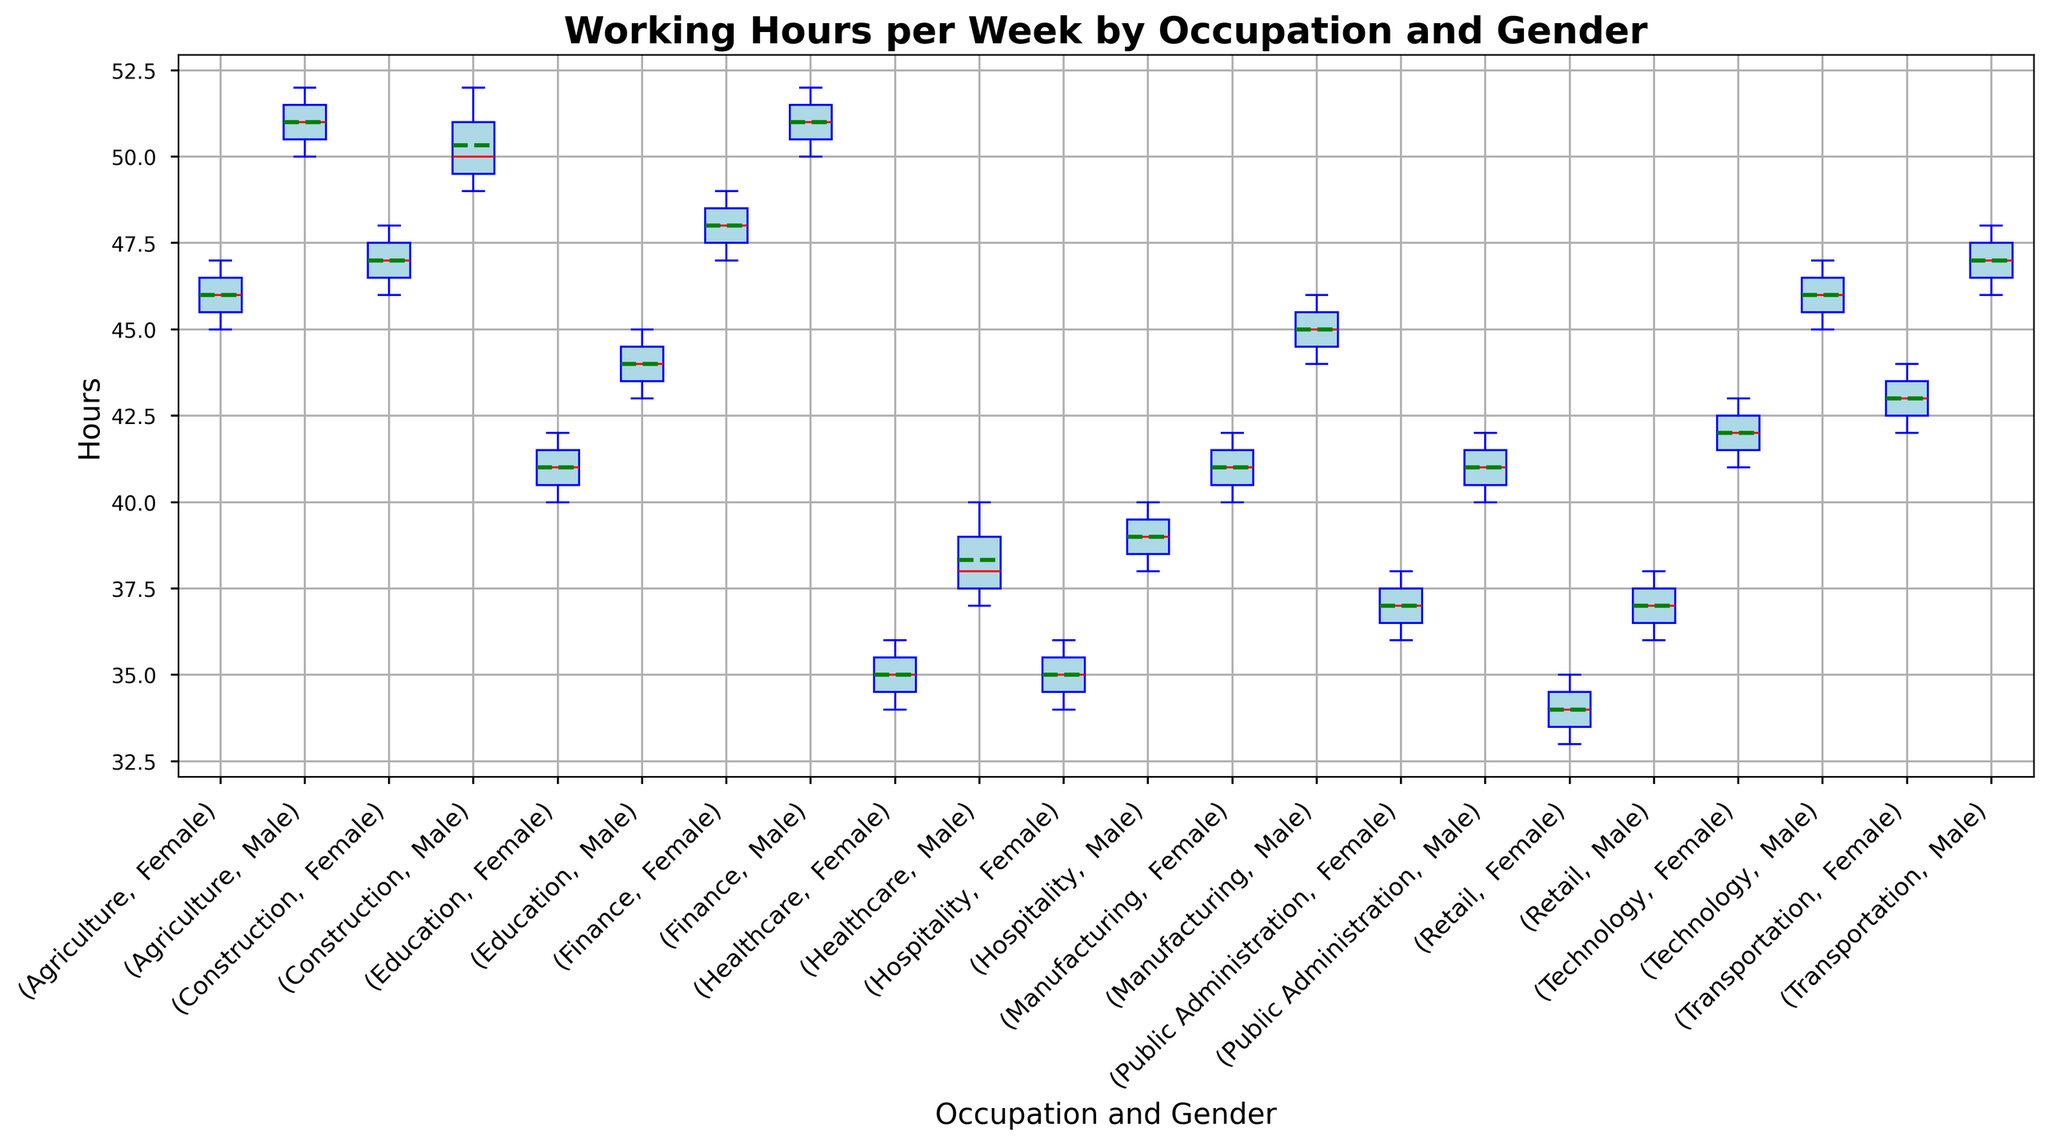What is the median working hours per week for females in the Healthcare sector? To find the median working hours for females in the Healthcare sector, locate the box plot corresponding to Healthcare females and observe the red line in the middle of the box.
Answer: 35 Which gender works more hours on average in the Finance sector? Compare the green dashed lines (representing the means) for males and females in the Finance sector. The mean is indicated by the green line, dashed for males and females.
Answer: Male What is the range of working hours for males in the Retail sector? For the range, identify the highest and lowest whiskers in the box plot for males in the Retail sector. Subtract the lowest value from the highest.
Answer: 2 Are the mean working hours for males in the Education sector greater than those of females in the same sector? Observe the green dashed lines for males and females in the Education box plot. Compare these lines to determine which is higher.
Answer: Yes Among males, which occupation has the highest median working hours? Look at the red median lines within the male box plots for all occupations, and identify the occupation where this line is the highest.
Answer: Finance Is the interquartile range (IQR) wider for males or females in the Healthcare sector? The IQR is the distance between the top and bottom edges of the box. Compare the heights of the boxes for males and females in the Healthcare sector.
Answer: Male Which occupation shows the smallest spread in working hours for either gender? Determine the spread by comparing the lengths of the whiskers and boxes across all occupations for both genders.
Answer: Retail Do females in the Technology sector have a higher median working hour than males in the Retail sector? Compare the red median line in the box plots for females in Technology and males in Retail.
Answer: Yes What is the difference in the average working hours between males in Construction and females in Agriculture? Locate the green dashed line (mean) for males in Construction and females in Agriculture, and calculate the difference.
Answer: 1 How do the medians of working hours for males in Agriculture and Finance compare? Compare the red median lines in the Agriculture male and Finance male box plots to determine which is higher.
Answer: Same 